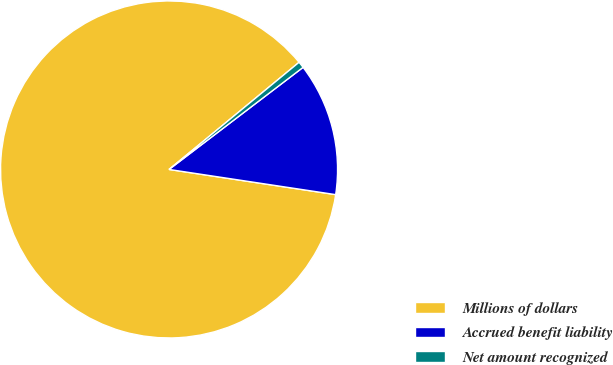Convert chart to OTSL. <chart><loc_0><loc_0><loc_500><loc_500><pie_chart><fcel>Millions of dollars<fcel>Accrued benefit liability<fcel>Net amount recognized<nl><fcel>86.65%<fcel>12.75%<fcel>0.61%<nl></chart> 